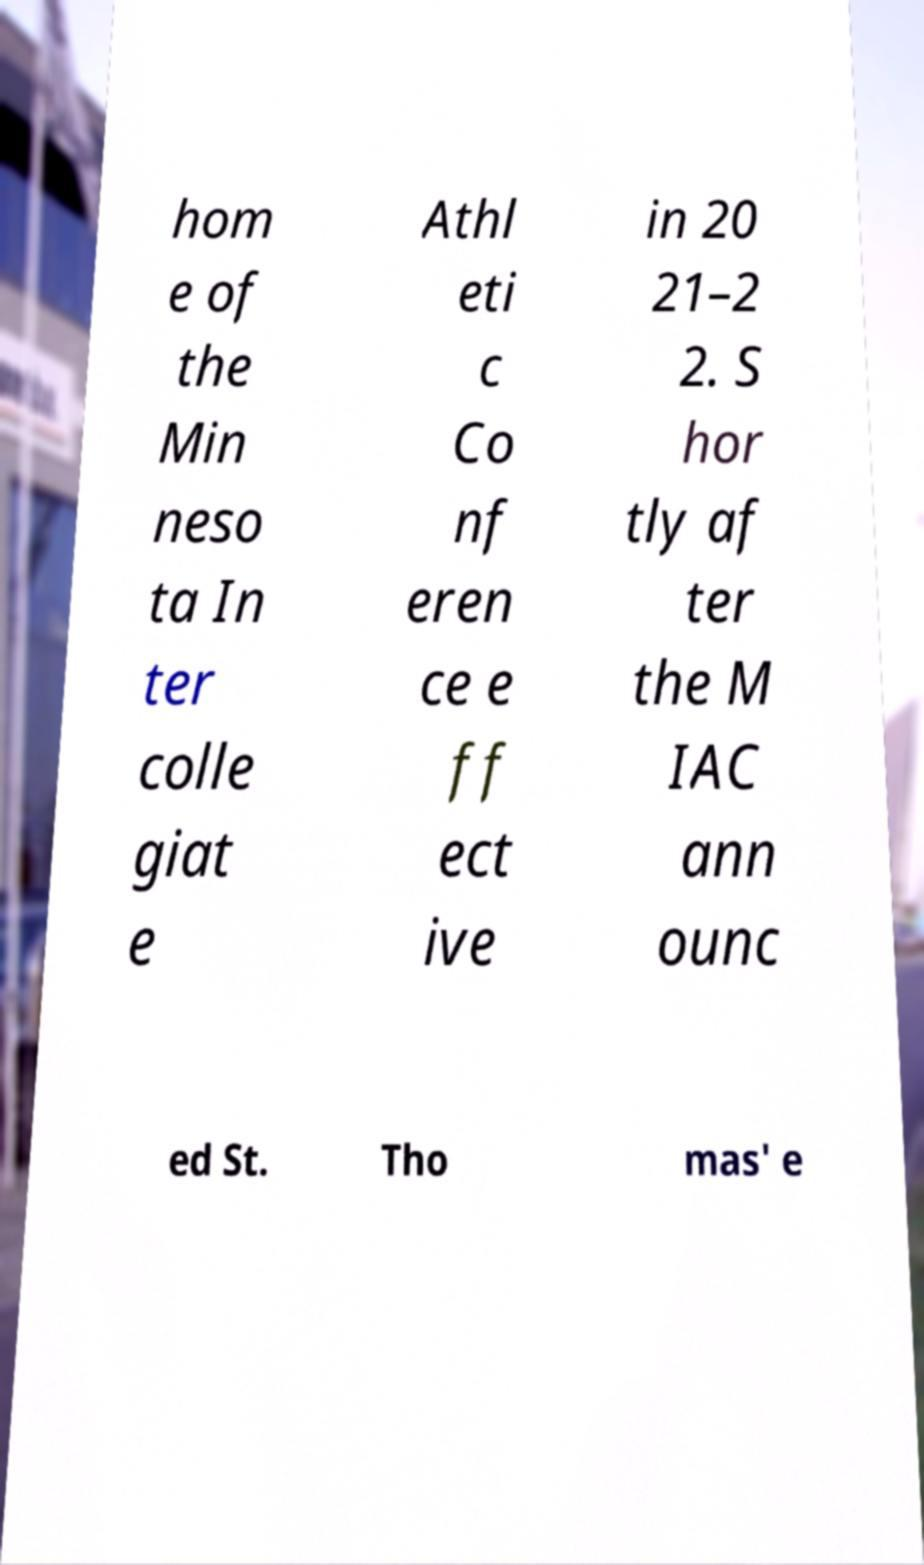Can you accurately transcribe the text from the provided image for me? hom e of the Min neso ta In ter colle giat e Athl eti c Co nf eren ce e ff ect ive in 20 21–2 2. S hor tly af ter the M IAC ann ounc ed St. Tho mas' e 